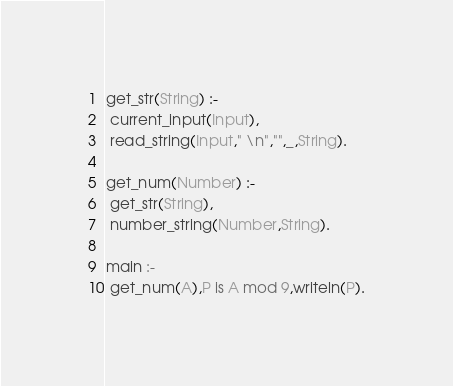Convert code to text. <code><loc_0><loc_0><loc_500><loc_500><_Prolog_>get_str(String) :-
 current_input(Input),
 read_string(Input," \n","",_,String).

get_num(Number) :-
 get_str(String),
 number_string(Number,String).

main :-
 get_num(A),P is A mod 9,writeln(P).</code> 